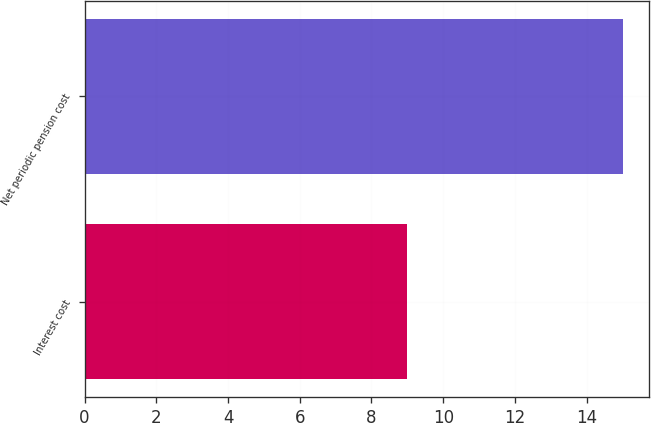<chart> <loc_0><loc_0><loc_500><loc_500><bar_chart><fcel>Interest cost<fcel>Net periodic pension cost<nl><fcel>9<fcel>15<nl></chart> 